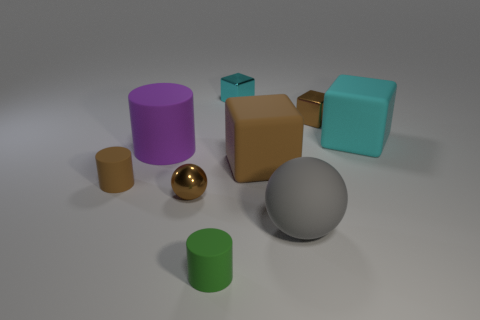Is there a tiny object that has the same color as the metal ball?
Make the answer very short. Yes. The rubber cube that is the same color as the metal ball is what size?
Offer a terse response. Large. How many other objects are there of the same size as the gray rubber object?
Provide a short and direct response. 3. Do the gray ball and the brown cylinder have the same size?
Provide a succinct answer. No. There is a large ball that is made of the same material as the big cyan object; what color is it?
Keep it short and to the point. Gray. What number of objects are metal spheres on the left side of the brown metal cube or big cyan matte things?
Provide a short and direct response. 2. There is a cyan object behind the big cyan thing; what is its size?
Make the answer very short. Small. Is the size of the gray matte ball the same as the ball behind the large gray ball?
Provide a succinct answer. No. There is a small rubber thing that is on the right side of the small brown shiny thing that is on the left side of the green rubber object; what is its color?
Your answer should be very brief. Green. How many other things are the same color as the matte ball?
Your answer should be compact. 0. 